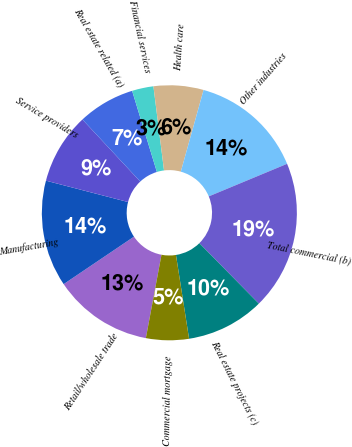<chart> <loc_0><loc_0><loc_500><loc_500><pie_chart><fcel>Retail/wholesale trade<fcel>Manufacturing<fcel>Service providers<fcel>Real estate related (a)<fcel>Financial services<fcel>Health care<fcel>Other industries<fcel>Total commercial (b)<fcel>Real estate projects (c)<fcel>Commercial mortgage<nl><fcel>12.6%<fcel>13.5%<fcel>9.01%<fcel>7.22%<fcel>2.72%<fcel>6.32%<fcel>14.4%<fcel>18.89%<fcel>9.91%<fcel>5.42%<nl></chart> 